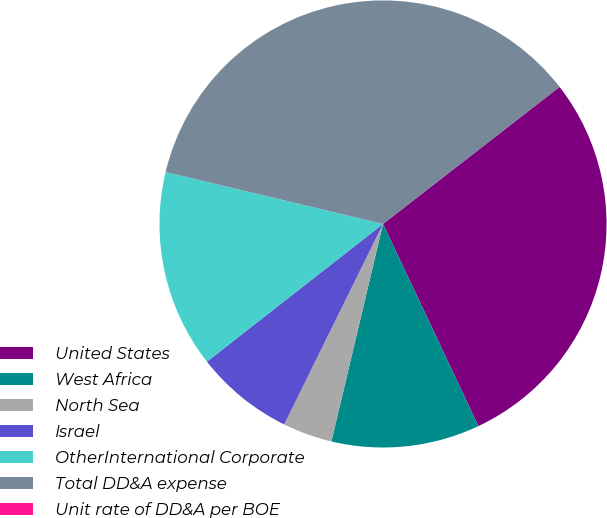Convert chart. <chart><loc_0><loc_0><loc_500><loc_500><pie_chart><fcel>United States<fcel>West Africa<fcel>North Sea<fcel>Israel<fcel>OtherInternational Corporate<fcel>Total DD&A expense<fcel>Unit rate of DD&A per BOE<nl><fcel>28.49%<fcel>10.73%<fcel>3.58%<fcel>7.15%<fcel>14.3%<fcel>35.76%<fcel>0.0%<nl></chart> 